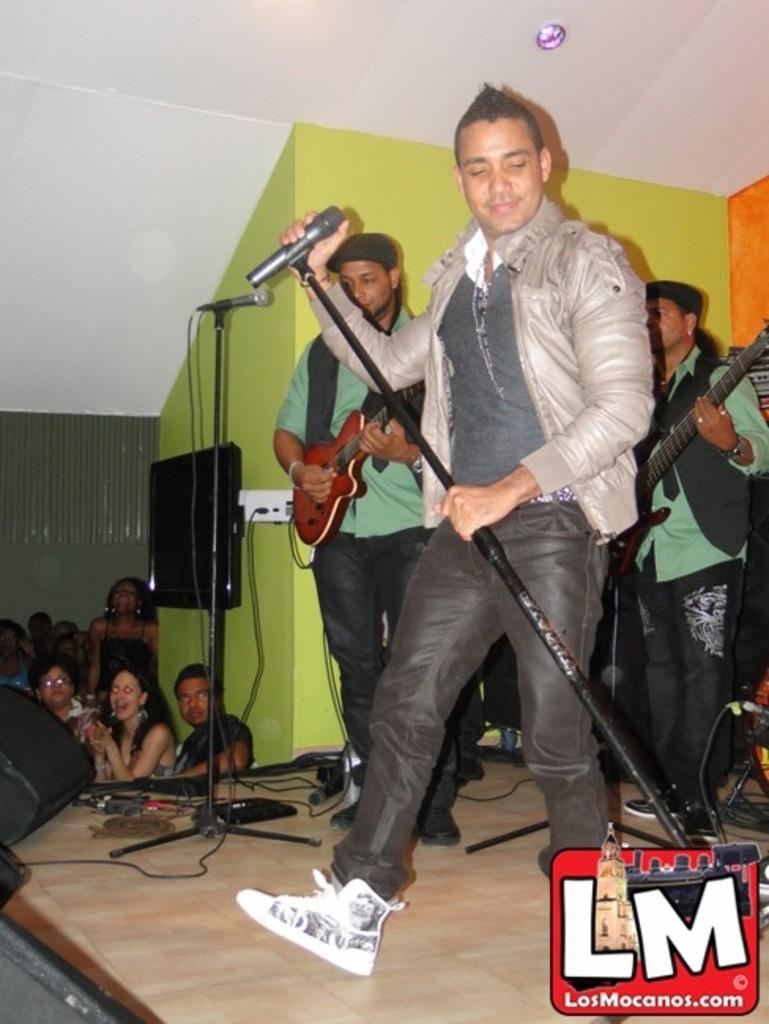Describe this image in one or two sentences. In this image we can see this person is standing on the stage and holding a mic in his hand. This people are playing guitar. In the background we can see people, monitor and wall. 